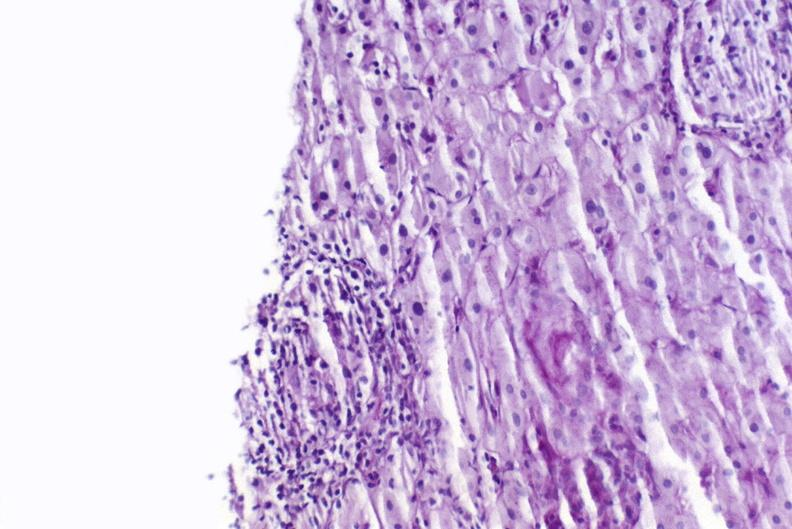s liver present?
Answer the question using a single word or phrase. Yes 